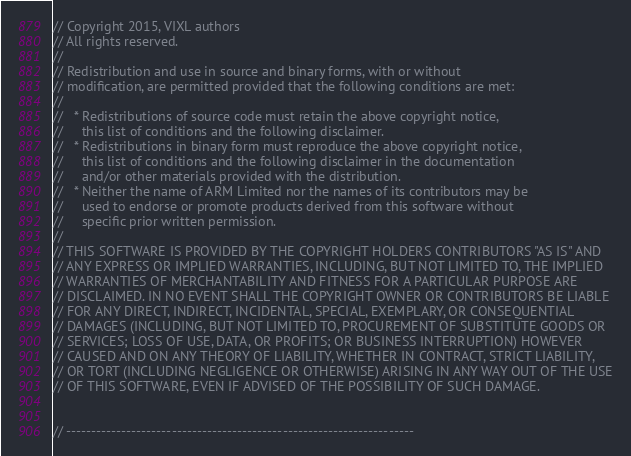Convert code to text. <code><loc_0><loc_0><loc_500><loc_500><_C_>// Copyright 2015, VIXL authors
// All rights reserved.
//
// Redistribution and use in source and binary forms, with or without
// modification, are permitted provided that the following conditions are met:
//
//   * Redistributions of source code must retain the above copyright notice,
//     this list of conditions and the following disclaimer.
//   * Redistributions in binary form must reproduce the above copyright notice,
//     this list of conditions and the following disclaimer in the documentation
//     and/or other materials provided with the distribution.
//   * Neither the name of ARM Limited nor the names of its contributors may be
//     used to endorse or promote products derived from this software without
//     specific prior written permission.
//
// THIS SOFTWARE IS PROVIDED BY THE COPYRIGHT HOLDERS CONTRIBUTORS "AS IS" AND
// ANY EXPRESS OR IMPLIED WARRANTIES, INCLUDING, BUT NOT LIMITED TO, THE IMPLIED
// WARRANTIES OF MERCHANTABILITY AND FITNESS FOR A PARTICULAR PURPOSE ARE
// DISCLAIMED. IN NO EVENT SHALL THE COPYRIGHT OWNER OR CONTRIBUTORS BE LIABLE
// FOR ANY DIRECT, INDIRECT, INCIDENTAL, SPECIAL, EXEMPLARY, OR CONSEQUENTIAL
// DAMAGES (INCLUDING, BUT NOT LIMITED TO, PROCUREMENT OF SUBSTITUTE GOODS OR
// SERVICES; LOSS OF USE, DATA, OR PROFITS; OR BUSINESS INTERRUPTION) HOWEVER
// CAUSED AND ON ANY THEORY OF LIABILITY, WHETHER IN CONTRACT, STRICT LIABILITY,
// OR TORT (INCLUDING NEGLIGENCE OR OTHERWISE) ARISING IN ANY WAY OUT OF THE USE
// OF THIS SOFTWARE, EVEN IF ADVISED OF THE POSSIBILITY OF SUCH DAMAGE.


// ---------------------------------------------------------------------</code> 